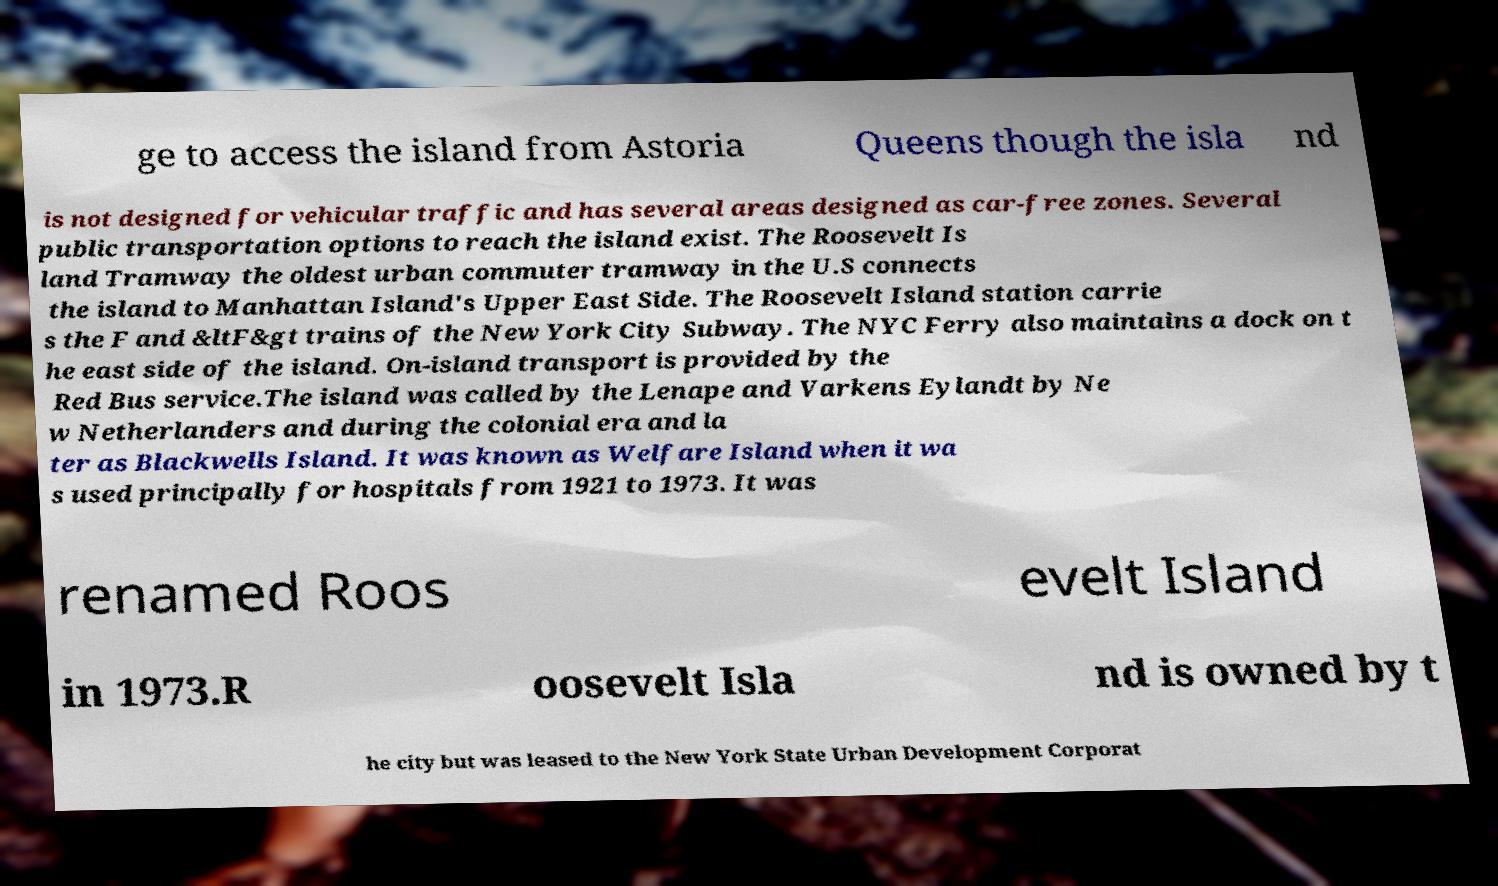I need the written content from this picture converted into text. Can you do that? ge to access the island from Astoria Queens though the isla nd is not designed for vehicular traffic and has several areas designed as car-free zones. Several public transportation options to reach the island exist. The Roosevelt Is land Tramway the oldest urban commuter tramway in the U.S connects the island to Manhattan Island's Upper East Side. The Roosevelt Island station carrie s the F and &ltF&gt trains of the New York City Subway. The NYC Ferry also maintains a dock on t he east side of the island. On-island transport is provided by the Red Bus service.The island was called by the Lenape and Varkens Eylandt by Ne w Netherlanders and during the colonial era and la ter as Blackwells Island. It was known as Welfare Island when it wa s used principally for hospitals from 1921 to 1973. It was renamed Roos evelt Island in 1973.R oosevelt Isla nd is owned by t he city but was leased to the New York State Urban Development Corporat 